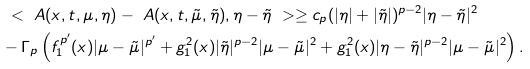Convert formula to latex. <formula><loc_0><loc_0><loc_500><loc_500>& \ < \ A ( x , t , \mu , \eta ) - \ A ( x , t , \tilde { \mu } , \tilde { \eta } ) , \eta - \tilde { \eta } \ > \geq c _ { p } ( | \eta | + | \tilde { \eta } | ) ^ { p - 2 } | \eta - \tilde { \eta } | ^ { 2 } \\ & - \Gamma _ { p } \left ( f _ { 1 } ^ { p ^ { \prime } } ( x ) | \mu - \tilde { \mu } | ^ { p ^ { \prime } } + g _ { 1 } ^ { 2 } ( x ) | \tilde { \eta } | ^ { p - 2 } | \mu - \tilde { \mu } | ^ { 2 } + g _ { 1 } ^ { 2 } ( x ) | \eta - \tilde { \eta } | ^ { p - 2 } | \mu - \tilde { \mu } | ^ { 2 } \right ) .</formula> 